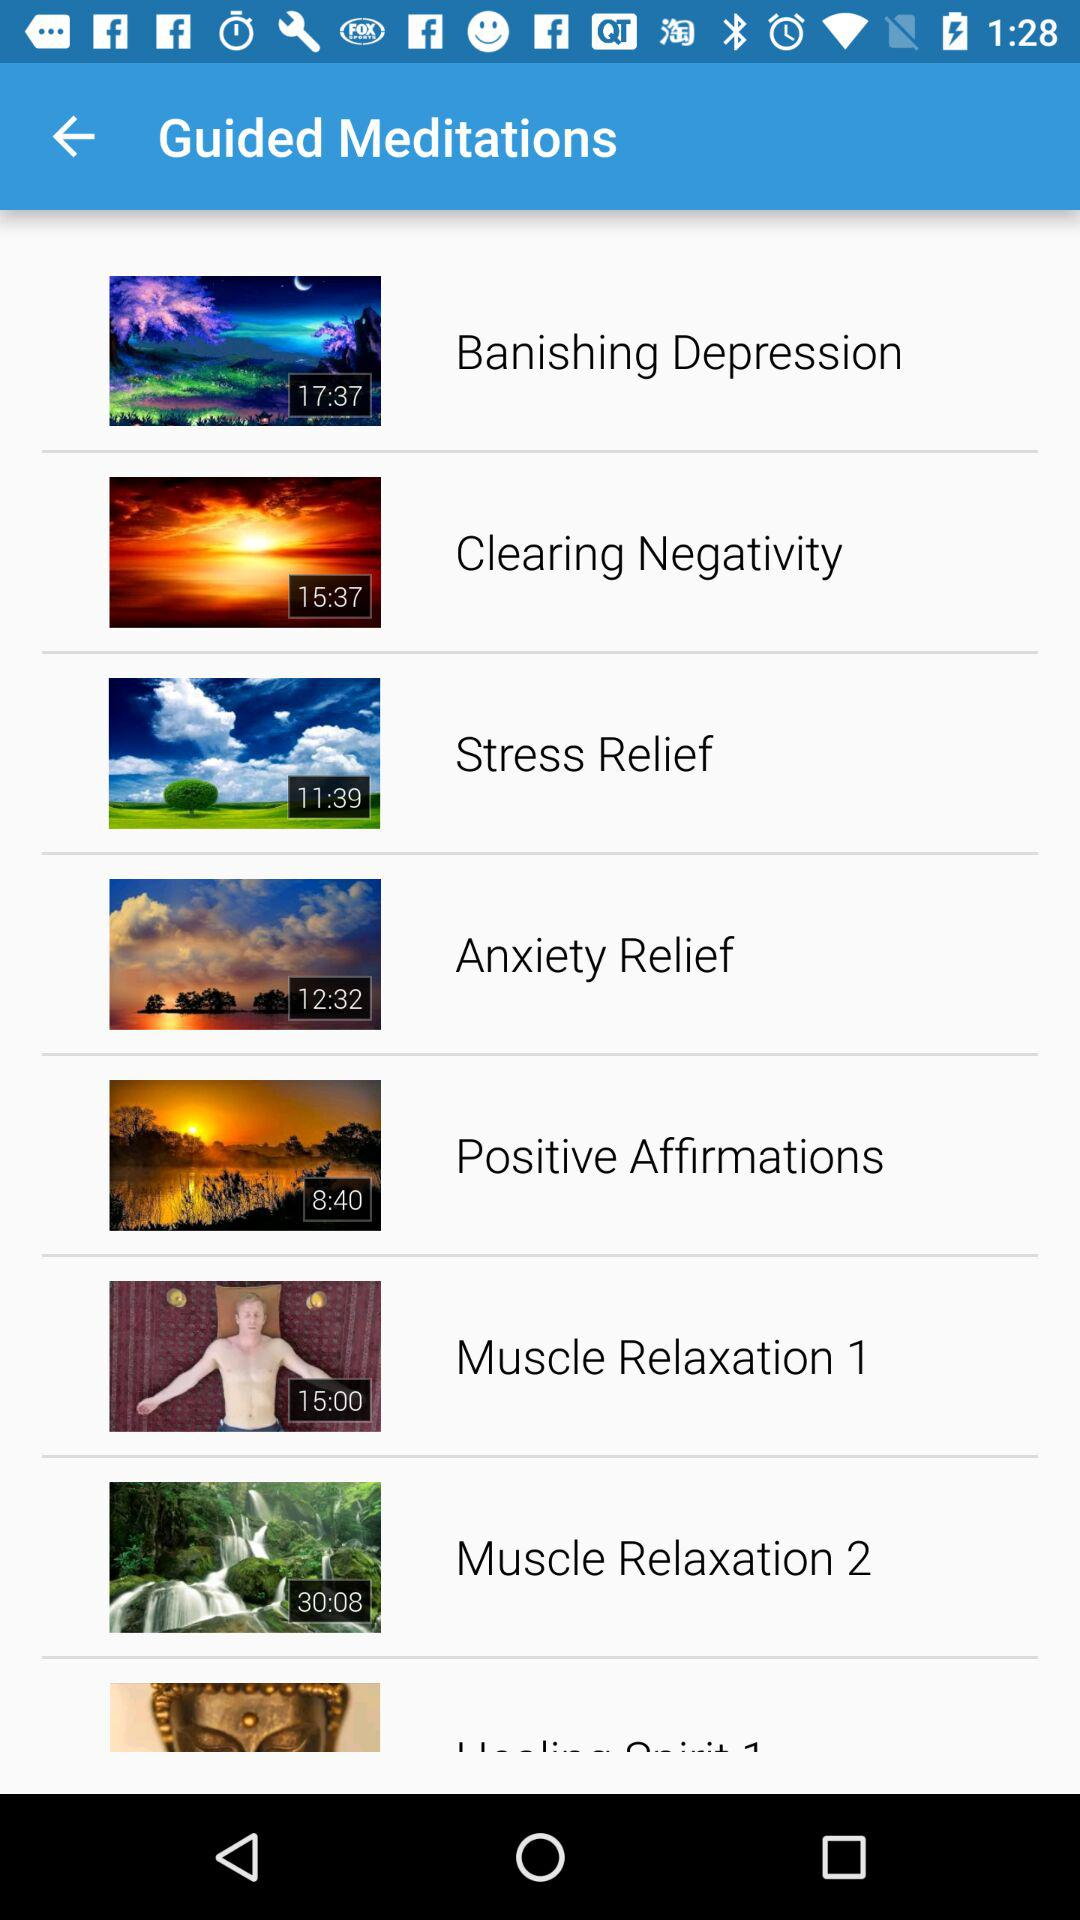What is the duration of stress-relief meditation? The duration is 11:39. 